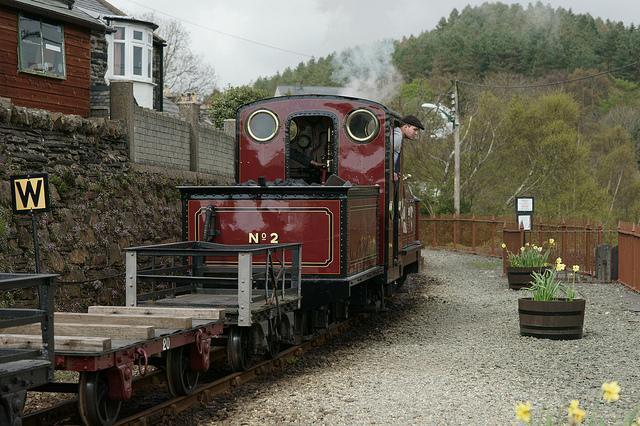Why are those flowers growing in those bins?
Make your selection and explain in format: 'Answer: answer
Rationale: rationale.'
Options: Bees, birds, weeds, gardener. Answer: gardener.
Rationale: There is a gardener who takes care of these flowers. 